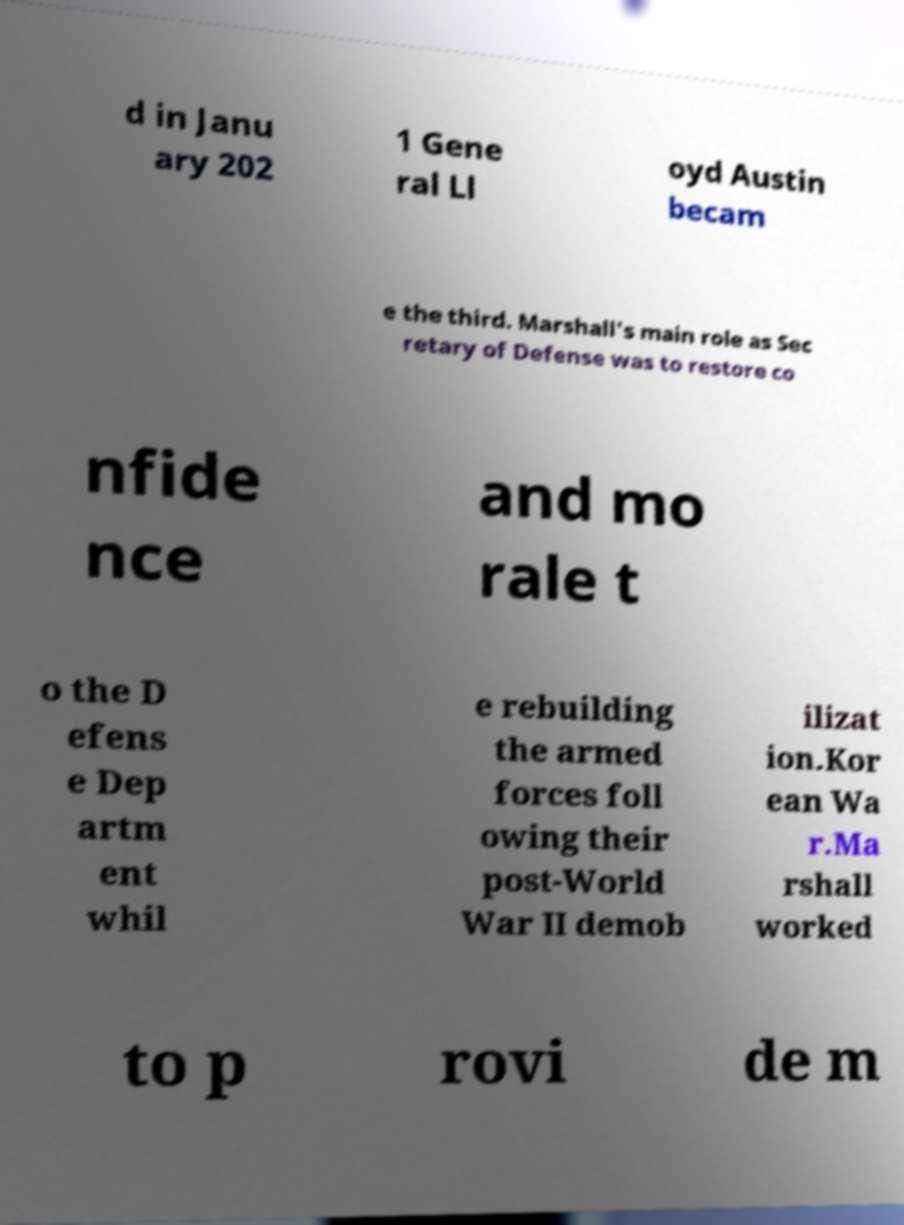I need the written content from this picture converted into text. Can you do that? d in Janu ary 202 1 Gene ral Ll oyd Austin becam e the third. Marshall's main role as Sec retary of Defense was to restore co nfide nce and mo rale t o the D efens e Dep artm ent whil e rebuilding the armed forces foll owing their post-World War II demob ilizat ion.Kor ean Wa r.Ma rshall worked to p rovi de m 